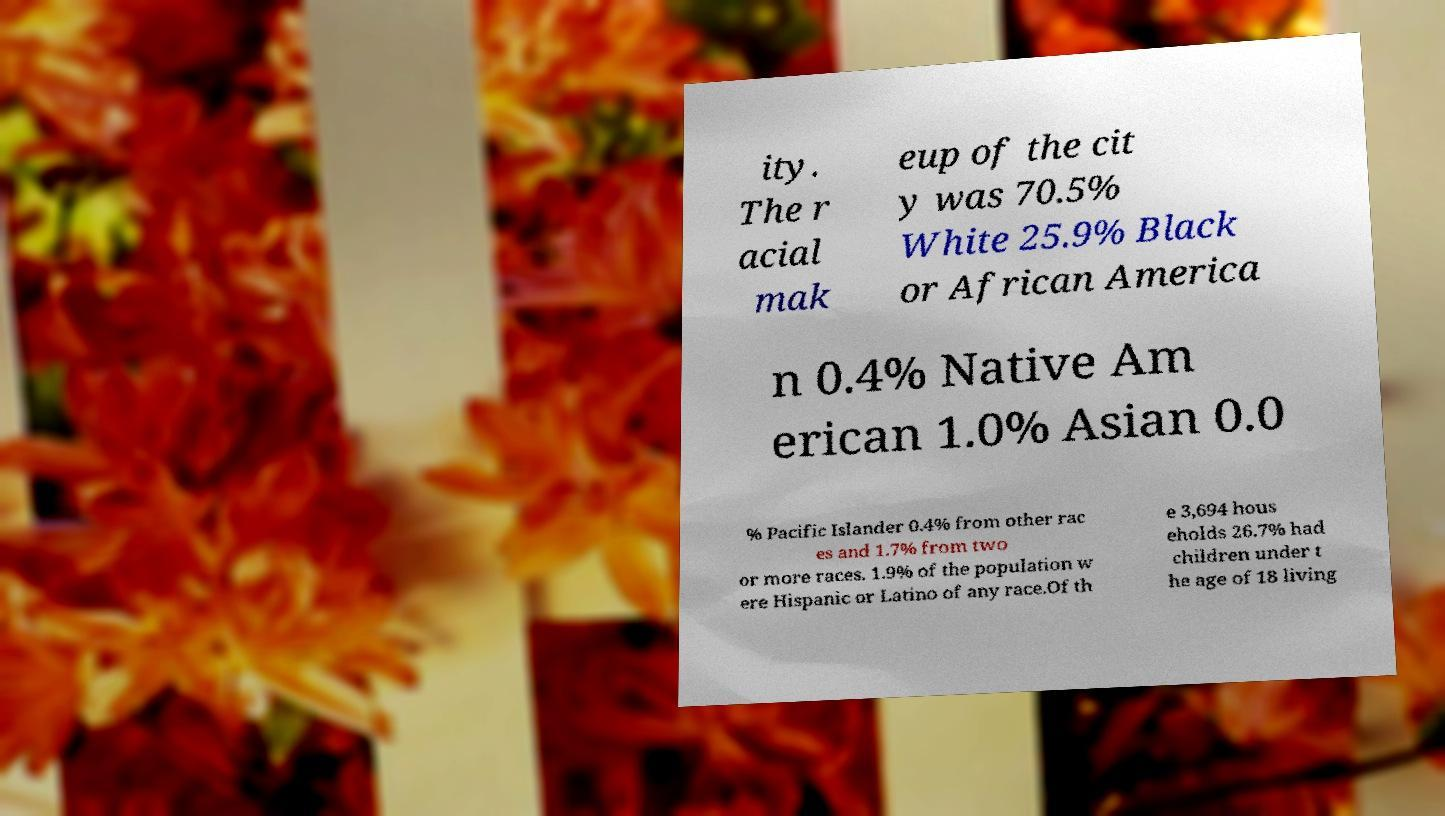Could you extract and type out the text from this image? ity. The r acial mak eup of the cit y was 70.5% White 25.9% Black or African America n 0.4% Native Am erican 1.0% Asian 0.0 % Pacific Islander 0.4% from other rac es and 1.7% from two or more races. 1.9% of the population w ere Hispanic or Latino of any race.Of th e 3,694 hous eholds 26.7% had children under t he age of 18 living 